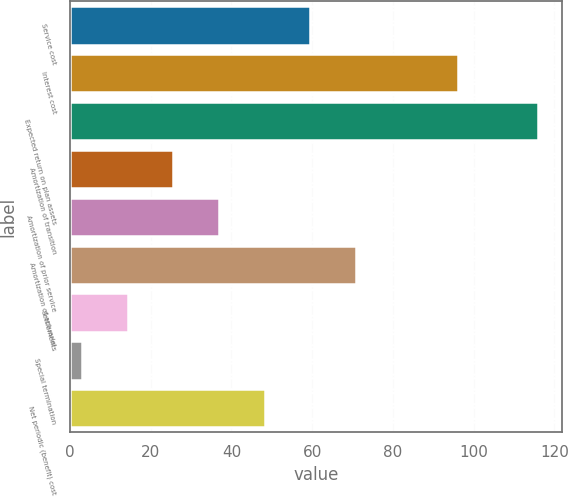Convert chart. <chart><loc_0><loc_0><loc_500><loc_500><bar_chart><fcel>Service cost<fcel>Interest cost<fcel>Expected return on plan assets<fcel>Amortization of transition<fcel>Amortization of prior service<fcel>Amortization of actuarial<fcel>Settlements<fcel>Special termination<fcel>Net periodic (benefit) cost<nl><fcel>59.51<fcel>96<fcel>116<fcel>25.64<fcel>36.93<fcel>70.8<fcel>14.35<fcel>3.06<fcel>48.22<nl></chart> 